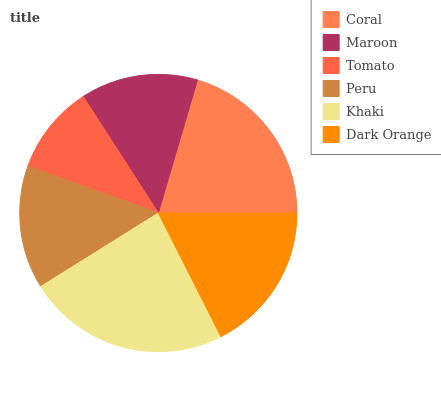Is Tomato the minimum?
Answer yes or no. Yes. Is Khaki the maximum?
Answer yes or no. Yes. Is Maroon the minimum?
Answer yes or no. No. Is Maroon the maximum?
Answer yes or no. No. Is Coral greater than Maroon?
Answer yes or no. Yes. Is Maroon less than Coral?
Answer yes or no. Yes. Is Maroon greater than Coral?
Answer yes or no. No. Is Coral less than Maroon?
Answer yes or no. No. Is Dark Orange the high median?
Answer yes or no. Yes. Is Peru the low median?
Answer yes or no. Yes. Is Coral the high median?
Answer yes or no. No. Is Tomato the low median?
Answer yes or no. No. 